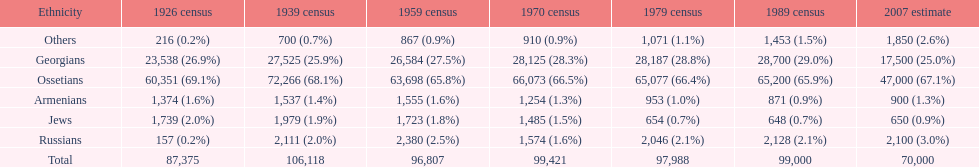What ethnicity is at the top? Ossetians. 